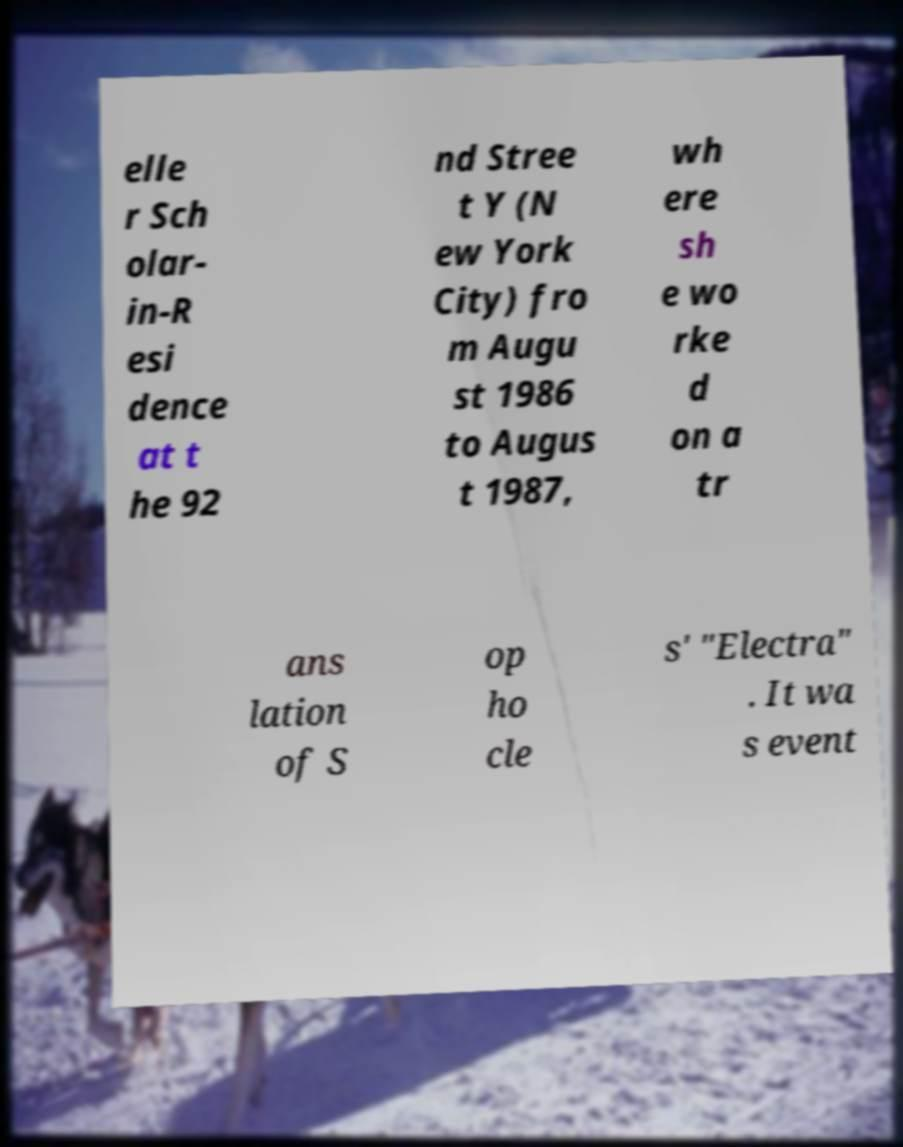Could you assist in decoding the text presented in this image and type it out clearly? elle r Sch olar- in-R esi dence at t he 92 nd Stree t Y (N ew York City) fro m Augu st 1986 to Augus t 1987, wh ere sh e wo rke d on a tr ans lation of S op ho cle s' "Electra" . It wa s event 